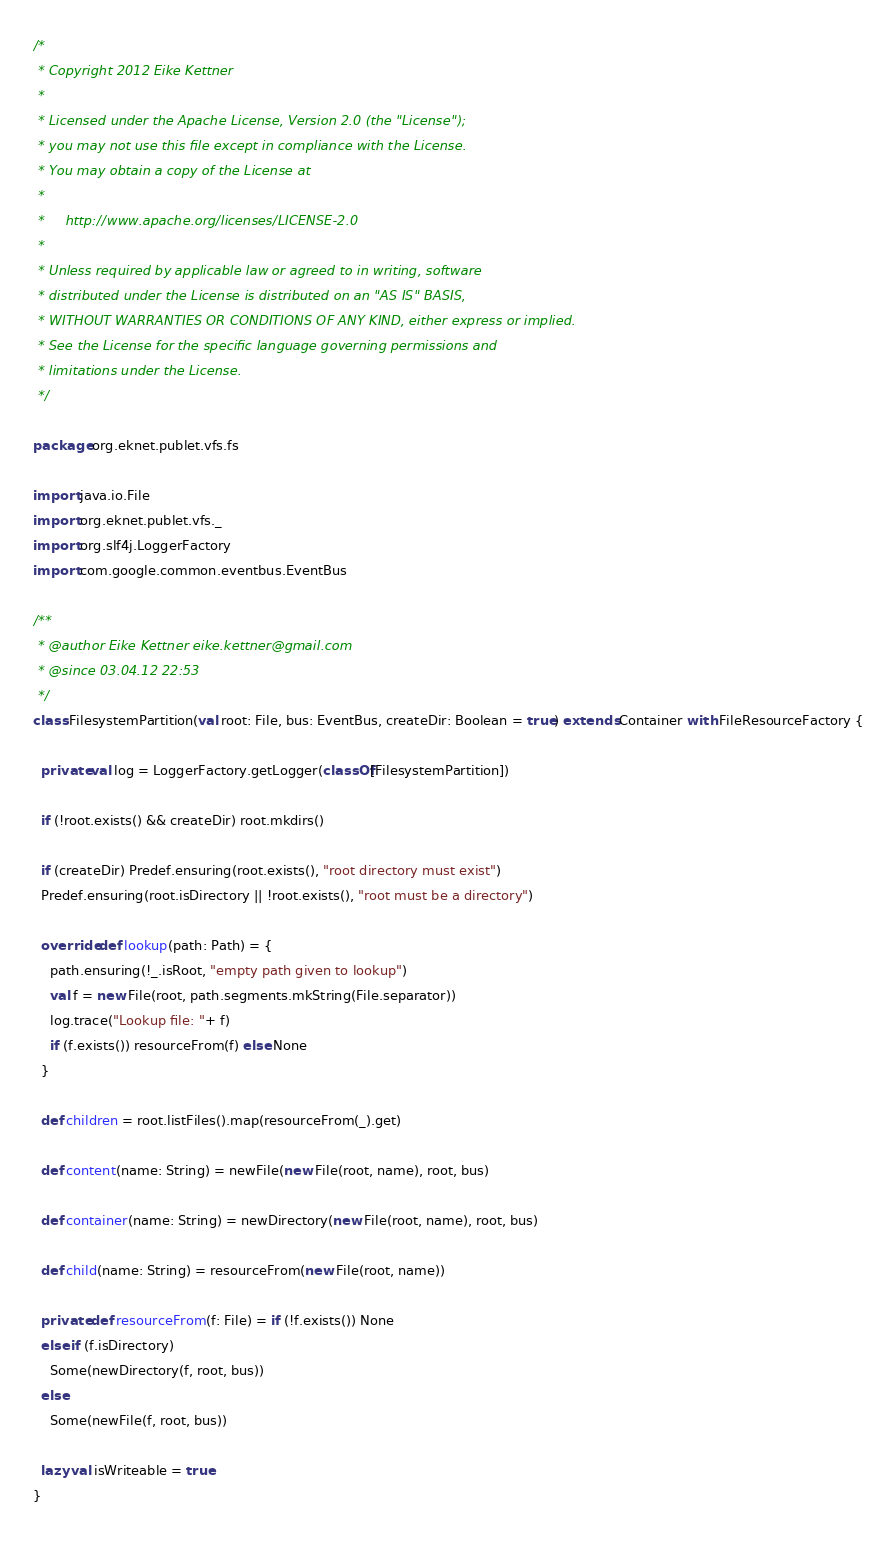Convert code to text. <code><loc_0><loc_0><loc_500><loc_500><_Scala_>/*
 * Copyright 2012 Eike Kettner
 *
 * Licensed under the Apache License, Version 2.0 (the "License");
 * you may not use this file except in compliance with the License.
 * You may obtain a copy of the License at
 *
 *     http://www.apache.org/licenses/LICENSE-2.0
 *
 * Unless required by applicable law or agreed to in writing, software
 * distributed under the License is distributed on an "AS IS" BASIS,
 * WITHOUT WARRANTIES OR CONDITIONS OF ANY KIND, either express or implied.
 * See the License for the specific language governing permissions and
 * limitations under the License.
 */

package org.eknet.publet.vfs.fs

import java.io.File
import org.eknet.publet.vfs._
import org.slf4j.LoggerFactory
import com.google.common.eventbus.EventBus

/**
 * @author Eike Kettner eike.kettner@gmail.com
 * @since 03.04.12 22:53
 */
class FilesystemPartition(val root: File, bus: EventBus, createDir: Boolean = true) extends Container with FileResourceFactory {

  private val log = LoggerFactory.getLogger(classOf[FilesystemPartition])

  if (!root.exists() && createDir) root.mkdirs()

  if (createDir) Predef.ensuring(root.exists(), "root directory must exist")
  Predef.ensuring(root.isDirectory || !root.exists(), "root must be a directory")

  override def lookup(path: Path) = {
    path.ensuring(!_.isRoot, "empty path given to lookup")
    val f = new File(root, path.segments.mkString(File.separator))
    log.trace("Lookup file: "+ f)
    if (f.exists()) resourceFrom(f) else None
  }

  def children = root.listFiles().map(resourceFrom(_).get)

  def content(name: String) = newFile(new File(root, name), root, bus)

  def container(name: String) = newDirectory(new File(root, name), root, bus)

  def child(name: String) = resourceFrom(new File(root, name))

  private def resourceFrom(f: File) = if (!f.exists()) None
  else if (f.isDirectory)
    Some(newDirectory(f, root, bus))
  else
    Some(newFile(f, root, bus))

  lazy val isWriteable = true
}
</code> 